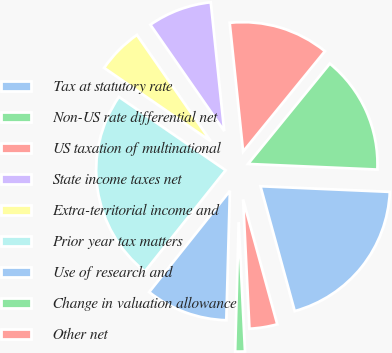<chart> <loc_0><loc_0><loc_500><loc_500><pie_chart><fcel>Tax at statutory rate<fcel>Non-US rate differential net<fcel>US taxation of multinational<fcel>State income taxes net<fcel>Extra-territorial income and<fcel>Prior year tax matters<fcel>Use of research and<fcel>Change in valuation allowance<fcel>Other net<nl><fcel>20.05%<fcel>14.81%<fcel>12.54%<fcel>8.01%<fcel>5.75%<fcel>23.87%<fcel>10.28%<fcel>1.22%<fcel>3.48%<nl></chart> 